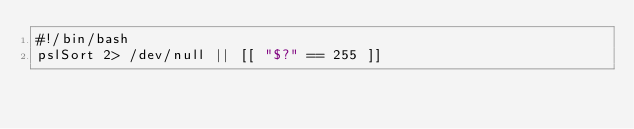Convert code to text. <code><loc_0><loc_0><loc_500><loc_500><_Bash_>#!/bin/bash
pslSort 2> /dev/null || [[ "$?" == 255 ]]
</code> 